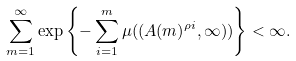<formula> <loc_0><loc_0><loc_500><loc_500>\sum _ { m = 1 } ^ { \infty } \exp \left \{ - \sum _ { i = 1 } ^ { m } \mu ( ( A ( m ) ^ { { \rho } i } , \infty ) ) \right \} < \infty .</formula> 